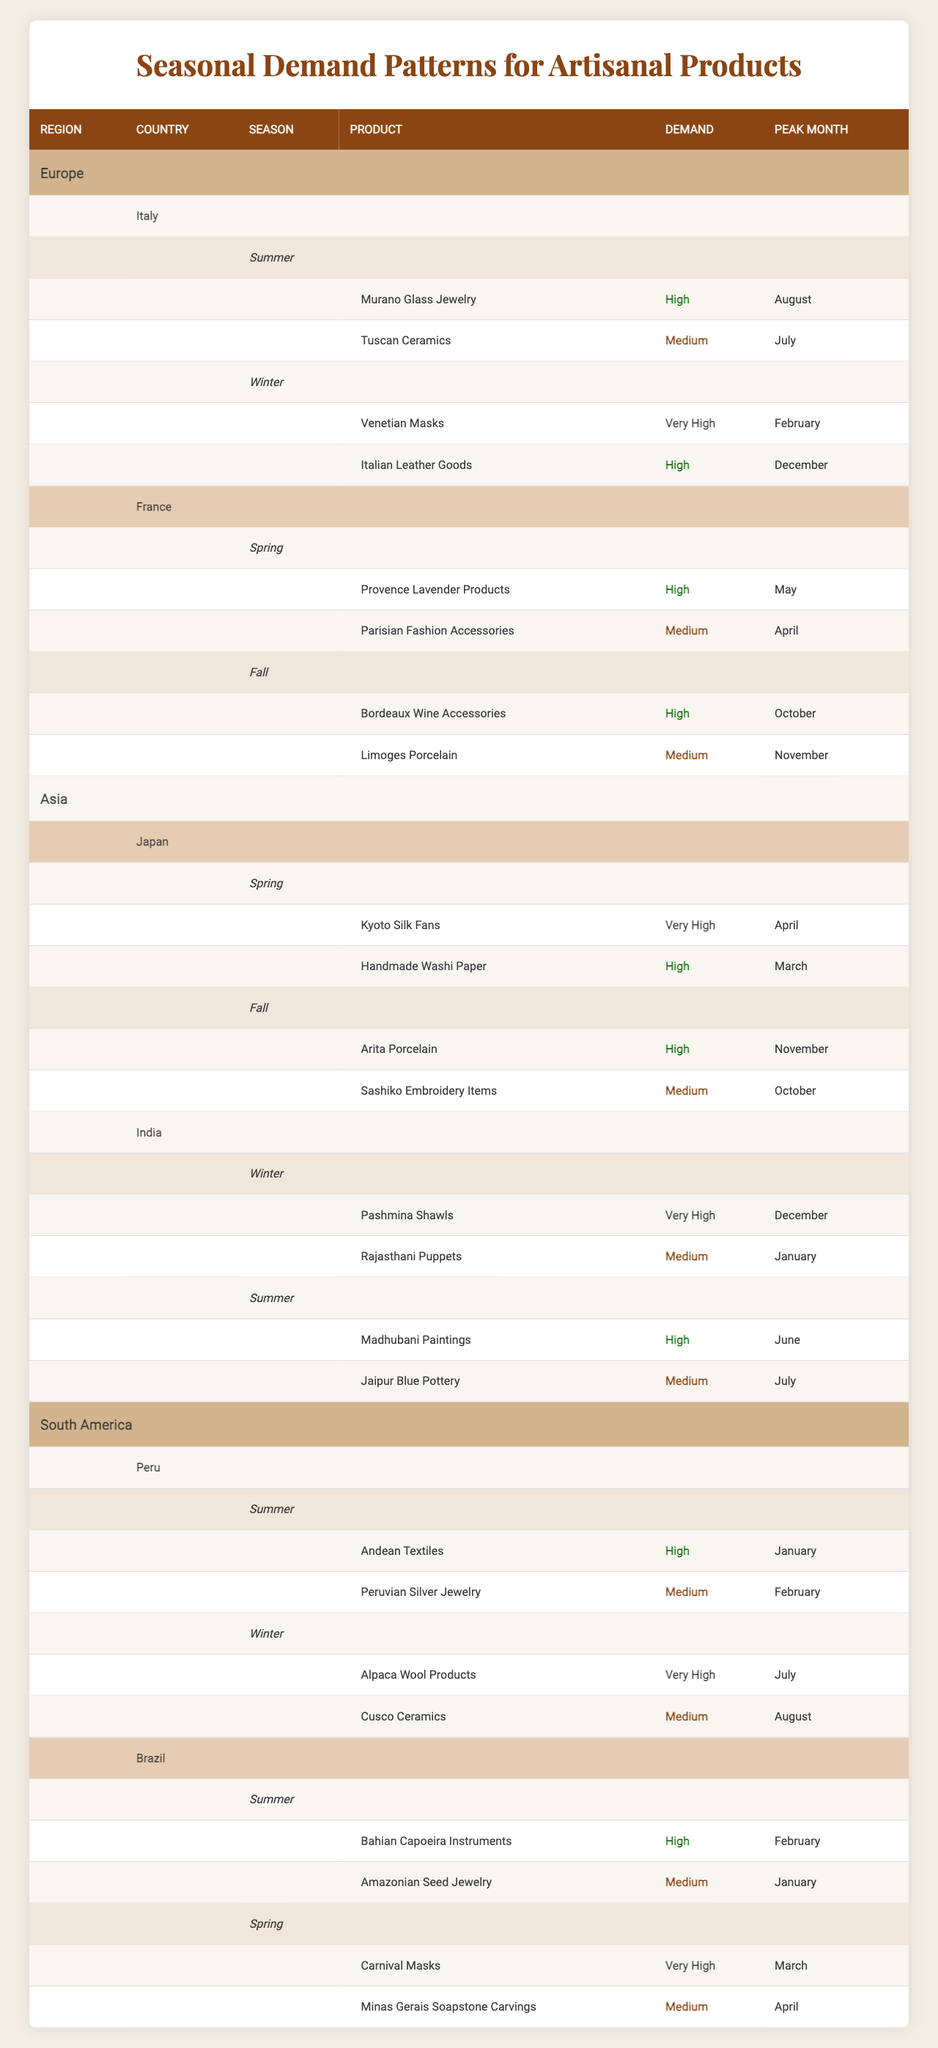What are the top products in Italy during summer? In the table, under Italy's summer season, the top products listed are Murano Glass Jewelry with "High" demand and Tuscan Ceramics with "Medium" demand.
Answer: Murano Glass Jewelry and Tuscan Ceramics Which country has very high demand for products in winter? The table reveals that India has very high demand for Pashmina Shawls during winter. Additionally, Italy has Venetian Masks with very high demand in the same season.
Answer: India and Italy What is the peak month for Venetian Masks? By examining the table, it is clear that the peak month for Venetian Masks, which have very high demand in winter, is February.
Answer: February Are there any products with medium demand in the spring season in Brazil? The table indicates that Brazil has medium demand for Minas Gerais Soapstone Carvings during the spring season.
Answer: Yes Which season sees the highest demand for handmade Washi Paper in Japan? The table states that handmade Washi Paper has high demand in spring, with the peak month being March.
Answer: Spring What is the difference in peak months between high and medium demand products in Peru during summer? In Peru's summer season, high demand products are Andean Textiles (January) and medium demand product is Peruvian Silver Jewelry (February). Therefore, the peak months differ by one month (February - January).
Answer: 1 month difference List the products that have very high demand and their corresponding peak months in the table. From the table, the products with very high demand are: Venetian Masks (February), Pashmina Shawls (December), Kyoto Silk Fans (April), and Carnival Masks (March).
Answer: Venetian Masks (February), Pashmina Shawls (December), Kyoto Silk Fans (April), Carnival Masks (March) During which season does France show high demand for Bordeaux Wine Accessories? According to the table, France shows high demand for Bordeaux Wine Accessories in the fall season, with October as the peak month.
Answer: Fall How many countries have top products with very high demand in the Spring season? The table shows that only Japan features a very high demand product (Kyoto Silk Fans) during the spring season, making it one country.
Answer: 1 country Which product has high demand in Italy during winter, and what is its peak month? The table shows that in Italy during winter, Italian Leather Goods have high demand and the peak month for these products is December.
Answer: Italian Leather Goods, December 